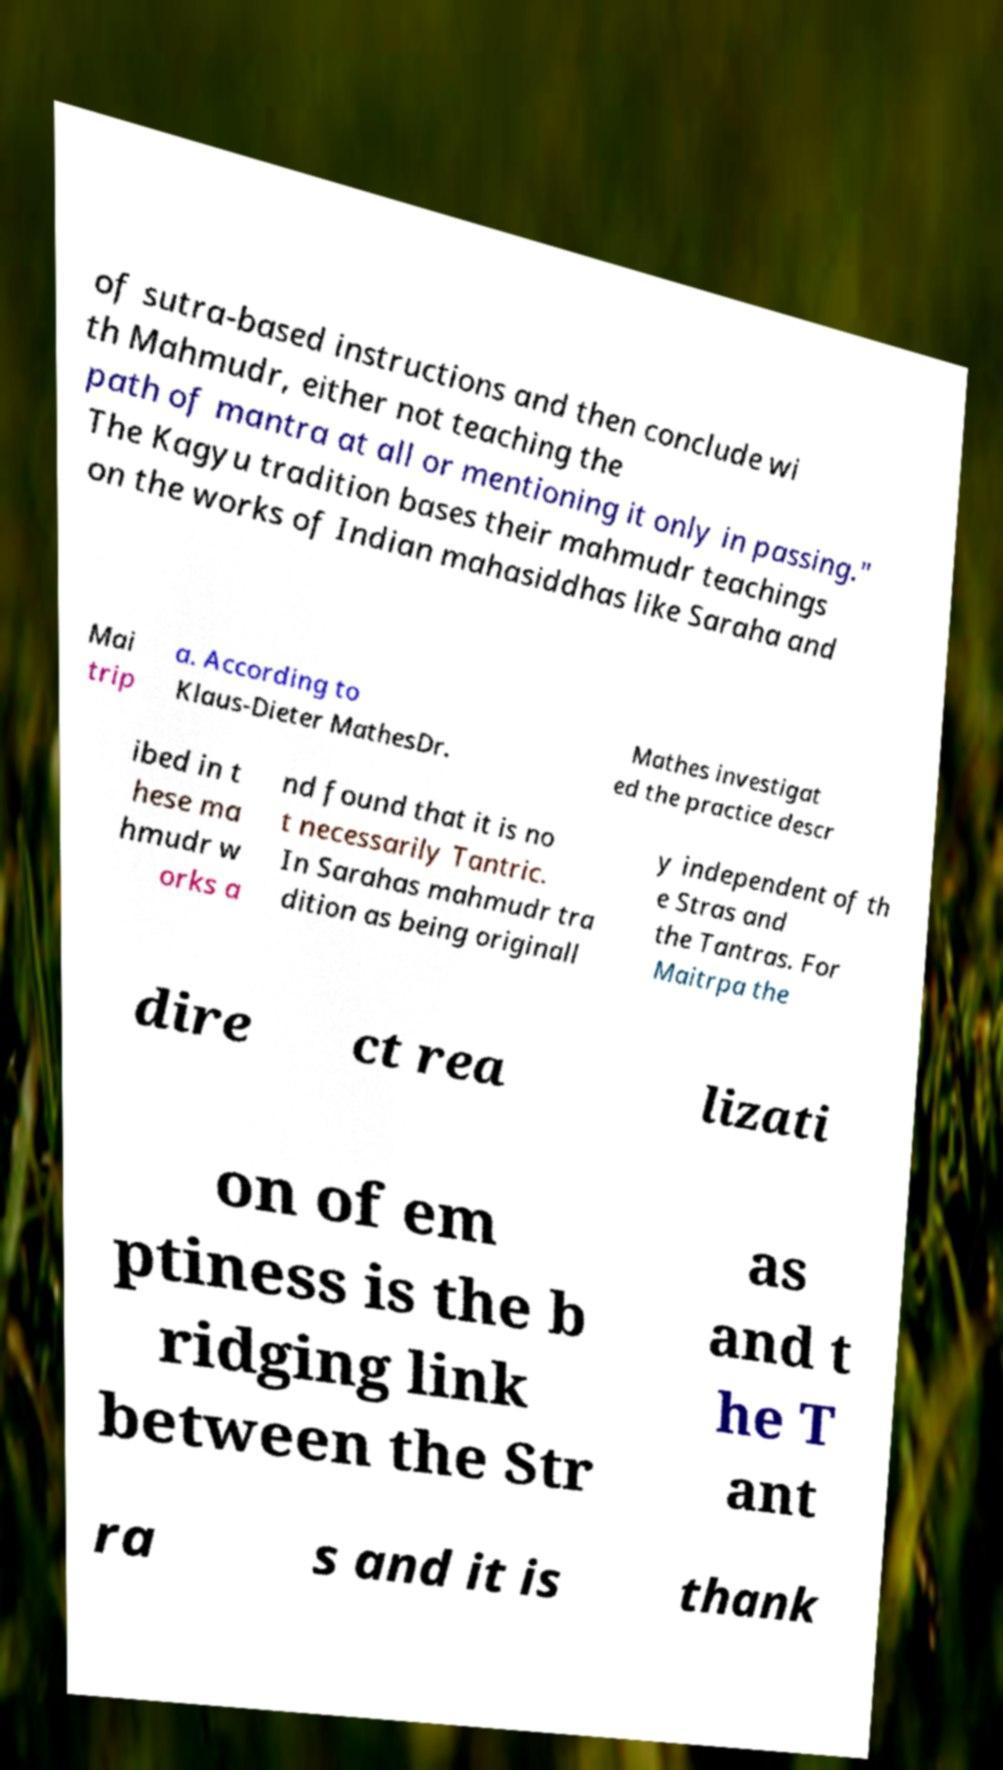Could you extract and type out the text from this image? of sutra-based instructions and then conclude wi th Mahmudr, either not teaching the path of mantra at all or mentioning it only in passing." The Kagyu tradition bases their mahmudr teachings on the works of Indian mahasiddhas like Saraha and Mai trip a. According to Klaus-Dieter MathesDr. Mathes investigat ed the practice descr ibed in t hese ma hmudr w orks a nd found that it is no t necessarily Tantric. In Sarahas mahmudr tra dition as being originall y independent of th e Stras and the Tantras. For Maitrpa the dire ct rea lizati on of em ptiness is the b ridging link between the Str as and t he T ant ra s and it is thank 